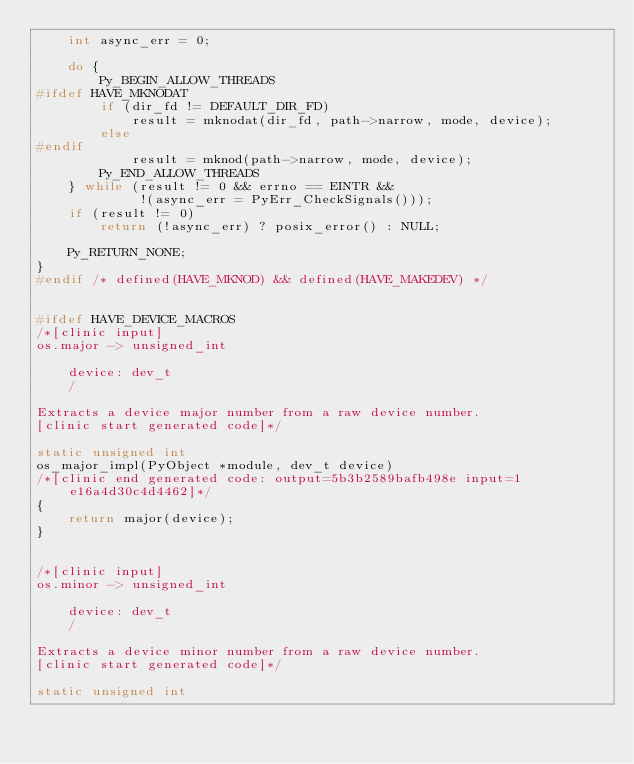<code> <loc_0><loc_0><loc_500><loc_500><_C_>    int async_err = 0;

    do {
        Py_BEGIN_ALLOW_THREADS
#ifdef HAVE_MKNODAT
        if (dir_fd != DEFAULT_DIR_FD)
            result = mknodat(dir_fd, path->narrow, mode, device);
        else
#endif
            result = mknod(path->narrow, mode, device);
        Py_END_ALLOW_THREADS
    } while (result != 0 && errno == EINTR &&
             !(async_err = PyErr_CheckSignals()));
    if (result != 0)
        return (!async_err) ? posix_error() : NULL;

    Py_RETURN_NONE;
}
#endif /* defined(HAVE_MKNOD) && defined(HAVE_MAKEDEV) */


#ifdef HAVE_DEVICE_MACROS
/*[clinic input]
os.major -> unsigned_int

    device: dev_t
    /

Extracts a device major number from a raw device number.
[clinic start generated code]*/

static unsigned int
os_major_impl(PyObject *module, dev_t device)
/*[clinic end generated code: output=5b3b2589bafb498e input=1e16a4d30c4d4462]*/
{
    return major(device);
}


/*[clinic input]
os.minor -> unsigned_int

    device: dev_t
    /

Extracts a device minor number from a raw device number.
[clinic start generated code]*/

static unsigned int</code> 